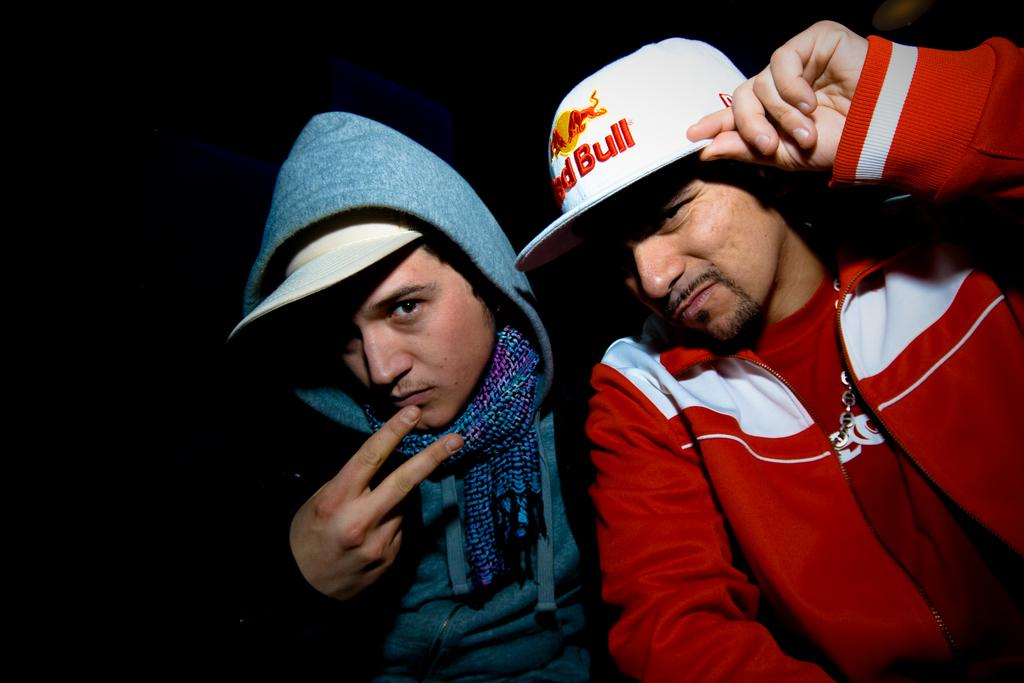Provide a one-sentence caption for the provided image. The man on the right is wearing a red bull hat. 